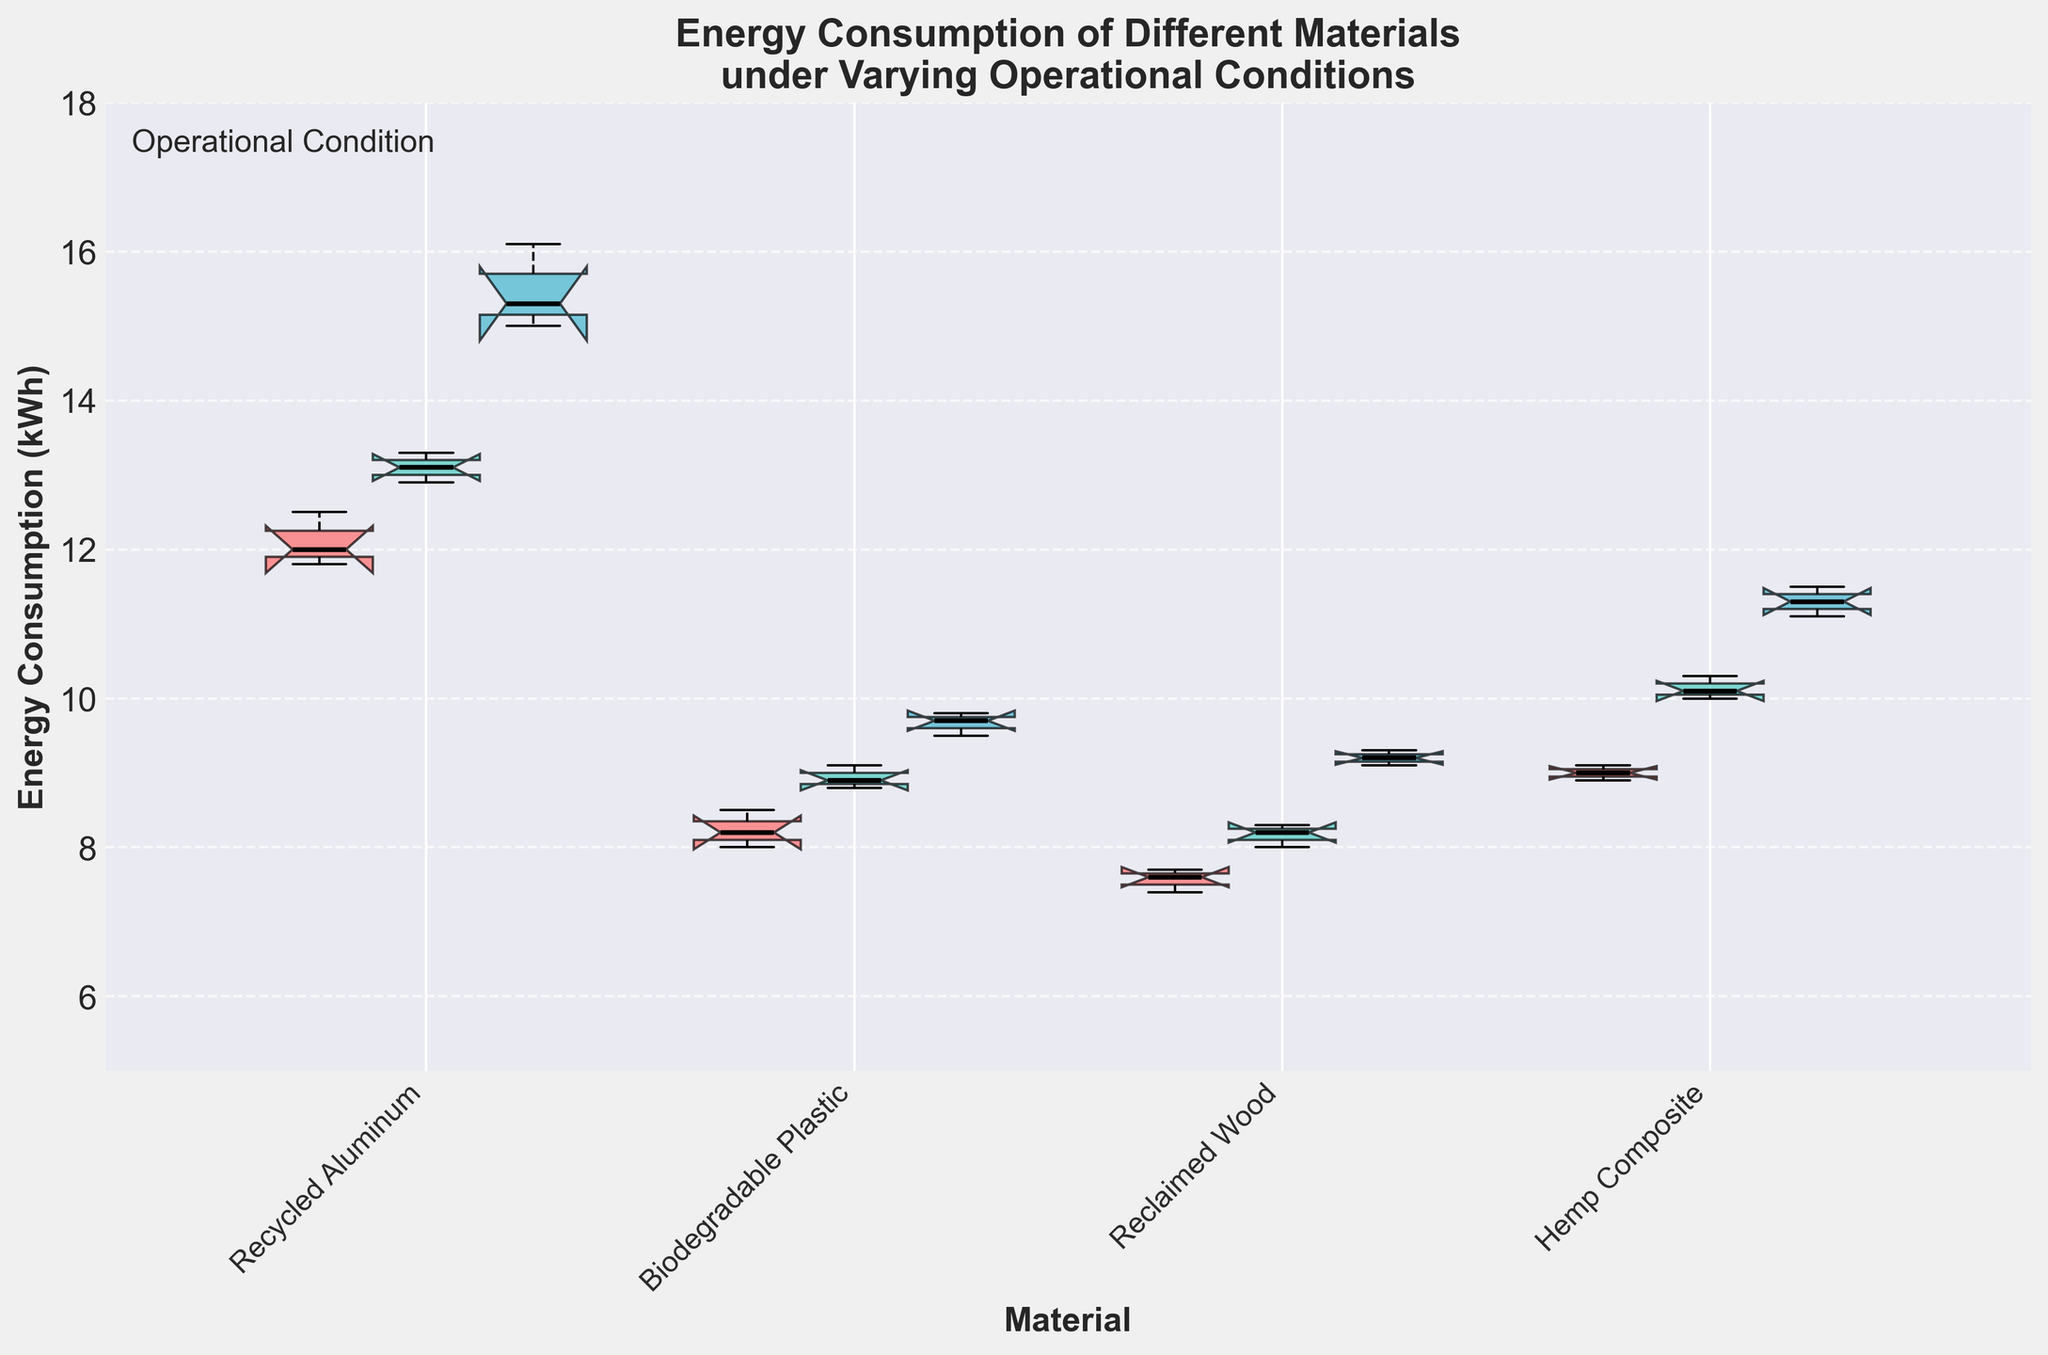What is the title of the plot? The title is located at the top center of the plot and reads, "Energy Consumption of Different Materials under Varying Operational Conditions".
Answer: Energy Consumption of Different Materials under Varying Operational Conditions How many materials are compared in the plot? The x-axis has labeled ticks for each material, which lists four materials: Recycled Aluminum, Biodegradable Plastic, Reclaimed Wood, and Hemp Composite.
Answer: 4 What is the range of energy consumption on the y-axis? The y-axis has labeled ticks which range from 5 to 18 kWh.
Answer: 5 to 18 kWh How does the median energy consumption of Recycled Aluminum under High Temperature compare to its consumption under Low Temperature? The notched box plot shows the median energy consumption line inside the box. The median for High Temperature appears around 15.7 kWh, and for Low Temperature, it's around 12.1 kWh, indicating High Temperature has higher consumption.
Answer: High Temperature is higher Which material has the least variability in energy consumption under Medium Temperature based on the interquartile range (IQR)? The IQR is the box length in box plots. Reclaimed Wood's box for Medium Temperature appears shortest among the materials, indicating the least variability.
Answer: Reclaimed Wood Which material and operational condition combination has the highest observed energy consumption? The upper whiskers show the highest observed energy values. For Recycled Aluminum under High Temperature, the whisker extends to about 16.1 kWh, which is the maximum point seen.
Answer: Recycled Aluminum High Temperature What is the median energy consumption of Biodegradable Plastic under Medium Temperature? The median value is marked by the black lines within the boxes. For Biodegradable Plastic under Medium Temperature, this line is close to 8.9 kWh.
Answer: 8.9 kWh Compare the median energy consumption of Hemp Composite under Low Temperature and High Temperature. What is the difference? The median for Low Temperature is around 9.0 kWh, and for High Temperature, it is around 11.3 kWh. Subtracting these, the difference is 11.3 - 9.0 = 2.3 kWh.
Answer: 2.3 kWh Which operational condition generally results in the highest energy consumption across all materials? Observing the boxes and whiskers for all materials, the High Temperature condition consistently shows the highest values in the plots.
Answer: High Temperature 